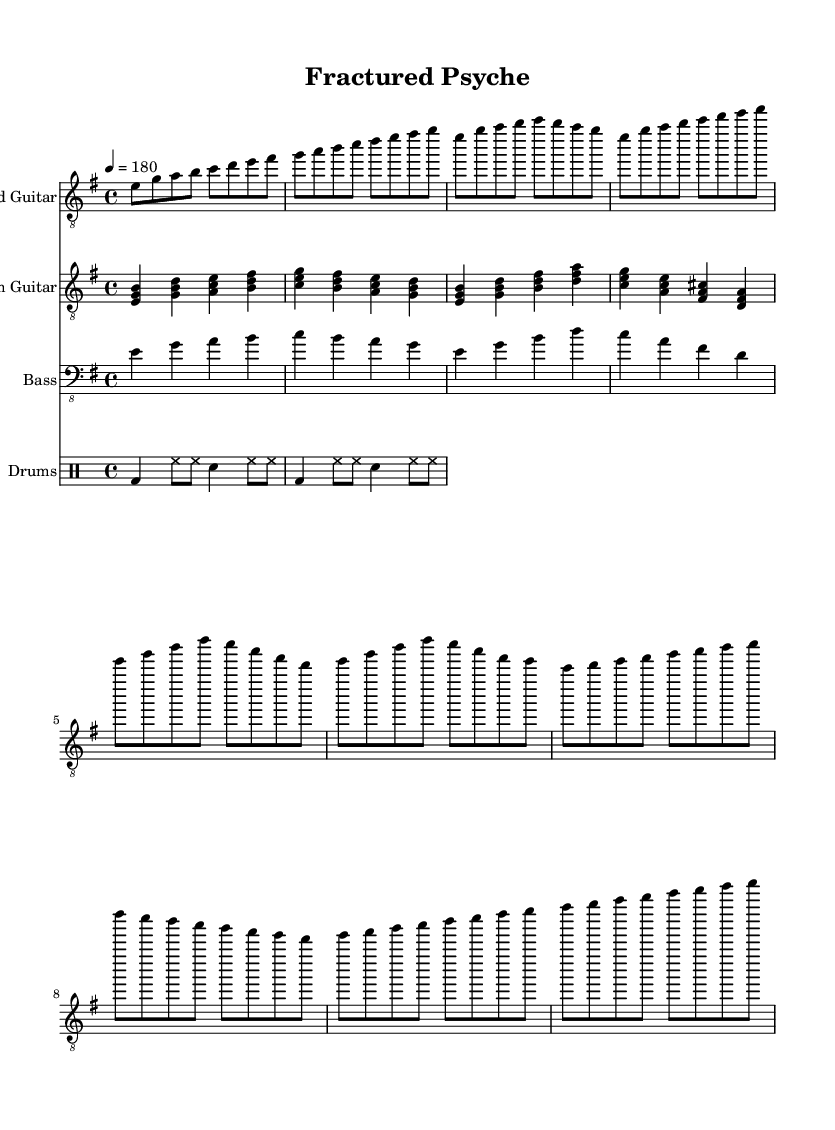What is the key signature of this music? The key signature is E minor, which has one sharp (F#). This can be identified by looking at the key signature at the beginning of the staff.
Answer: E minor What is the time signature of this music? The time signature is 4/4, which means there are four beats in each measure and the quarter note receives one beat. This is indicated at the beginning of the score where the time signature is marked.
Answer: 4/4 What is the tempo marking for this piece? The tempo marking is 180 beats per minute. This is found at the beginning of the score next to the tempo indication.
Answer: 180 How many measures are in the lead guitar part? There are 18 measures in the lead guitar part. By counting the groups of notes separated by bar lines in the lead guitar staff, we reach this total.
Answer: 18 What type of scales does the lead guitar feature prominently? The lead guitar features the E minor scale, as demonstrated by the use of the notes E, G, A, B, C, D, and F# throughout the part. This can be observed through the notes used in both the verses and choruses.
Answer: E minor scale Describe a structural characteristic of the chorus in this music. The chorus has a distinct melodic rise and fall pattern, characterized by the movement from E to higher pitches and then back down, which is typical in melodic death metal to evoke emotional depth. This observation comes from analyzing the pattern of notes used in the chorus section.
Answer: Distinct melodic rise and fall pattern What instrument plays the primary rhythm in this piece? The rhythm guitar plays the primary rhythm, providing harmonic support and rhythmic consistency throughout the music, which is common in metal compositions. This is evident from the notation written for the rhythm guitar in the score.
Answer: Rhythm guitar 